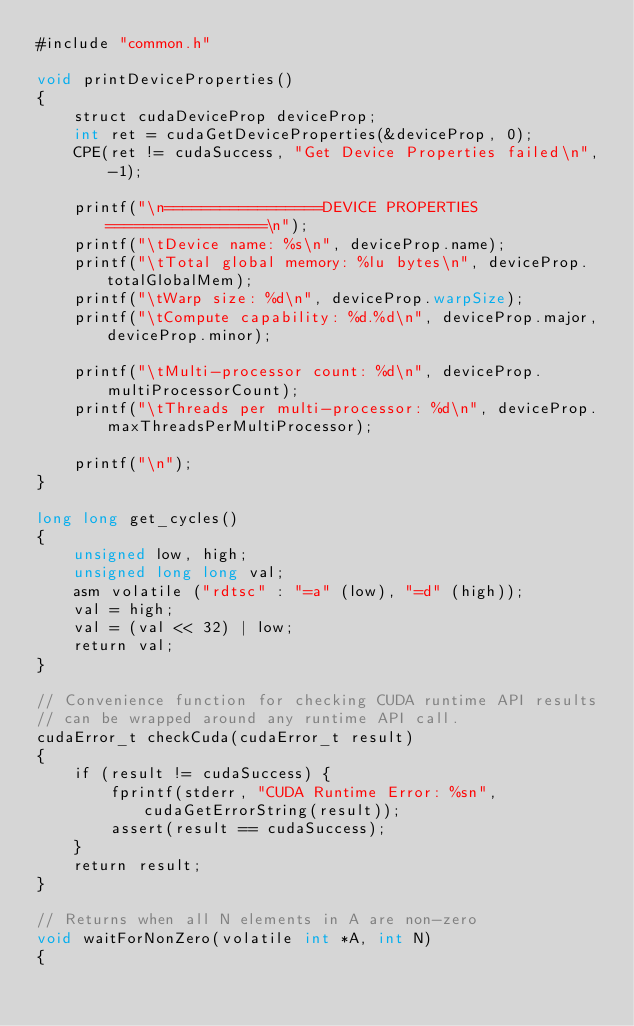Convert code to text. <code><loc_0><loc_0><loc_500><loc_500><_Cuda_>#include "common.h"

void printDeviceProperties()
{
	struct cudaDeviceProp deviceProp;
	int ret = cudaGetDeviceProperties(&deviceProp, 0);
	CPE(ret != cudaSuccess, "Get Device Properties failed\n", -1);

	printf("\n=================DEVICE PROPERTIES=================\n");
	printf("\tDevice name: %s\n", deviceProp.name);
	printf("\tTotal global memory: %lu bytes\n", deviceProp.totalGlobalMem);
	printf("\tWarp size: %d\n", deviceProp.warpSize);
	printf("\tCompute capability: %d.%d\n", deviceProp.major, deviceProp.minor);

	printf("\tMulti-processor count: %d\n", deviceProp.multiProcessorCount);
	printf("\tThreads per multi-processor: %d\n", deviceProp.maxThreadsPerMultiProcessor);

	printf("\n");
}

long long get_cycles()
{
	unsigned low, high;
	unsigned long long val;
	asm volatile ("rdtsc" : "=a" (low), "=d" (high));
	val = high;
	val = (val << 32) | low;
	return val;
}

// Convenience function for checking CUDA runtime API results
// can be wrapped around any runtime API call.
cudaError_t checkCuda(cudaError_t result)
{
	if (result != cudaSuccess) {
		fprintf(stderr, "CUDA Runtime Error: %sn", cudaGetErrorString(result));
		assert(result == cudaSuccess);
	}
	return result;
}

// Returns when all N elements in A are non-zero
void waitForNonZero(volatile int *A, int N)
{</code> 